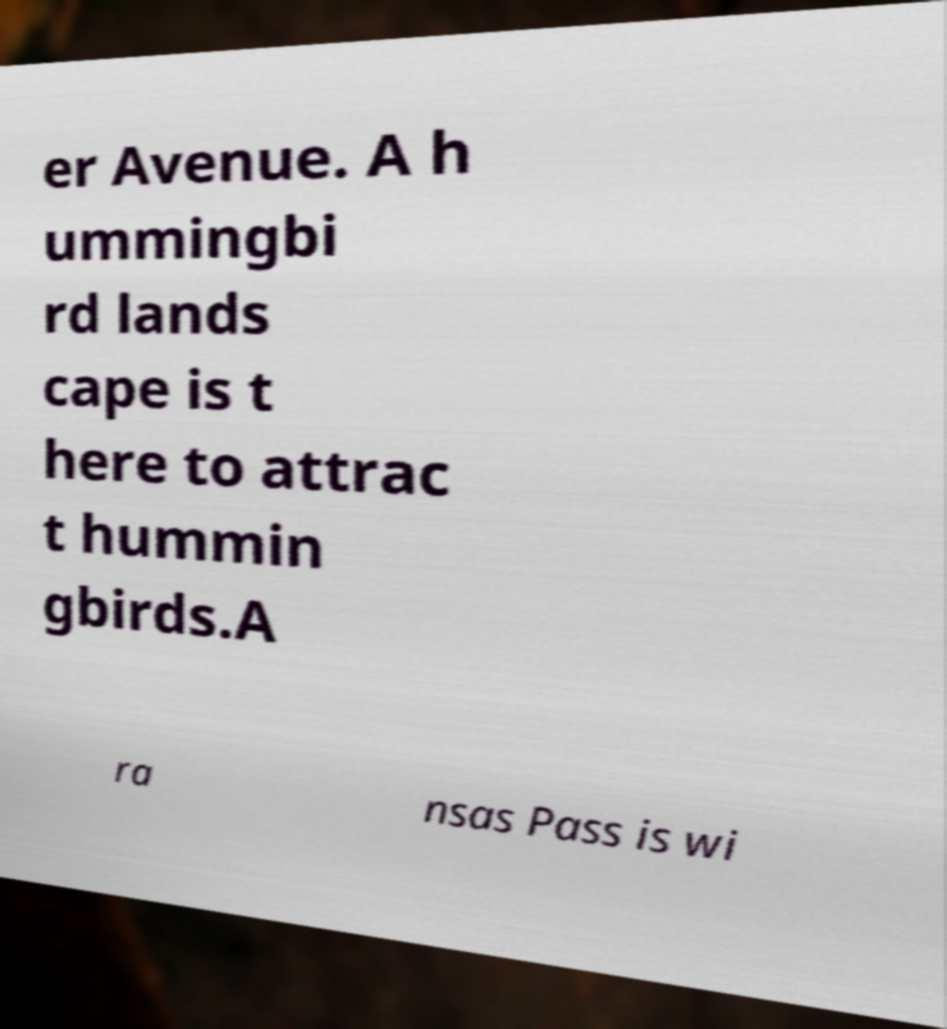Can you read and provide the text displayed in the image?This photo seems to have some interesting text. Can you extract and type it out for me? er Avenue. A h ummingbi rd lands cape is t here to attrac t hummin gbirds.A ra nsas Pass is wi 